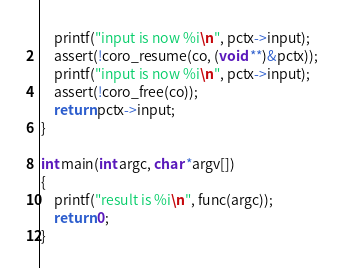Convert code to text. <code><loc_0><loc_0><loc_500><loc_500><_C_>	printf("input is now %i\n", pctx->input);
	assert(!coro_resume(co, (void **)&pctx));
	printf("input is now %i\n", pctx->input);
	assert(!coro_free(co));
	return pctx->input;
}

int main(int argc, char *argv[])
{
	printf("result is %i\n", func(argc));
	return 0;
}
</code> 